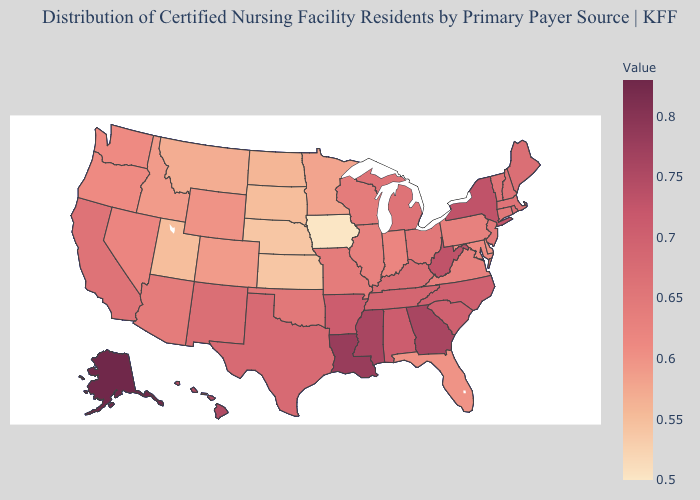Does Rhode Island have the lowest value in the Northeast?
Be succinct. No. Is the legend a continuous bar?
Quick response, please. Yes. 